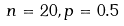<formula> <loc_0><loc_0><loc_500><loc_500>n = 2 0 , p = 0 . 5</formula> 